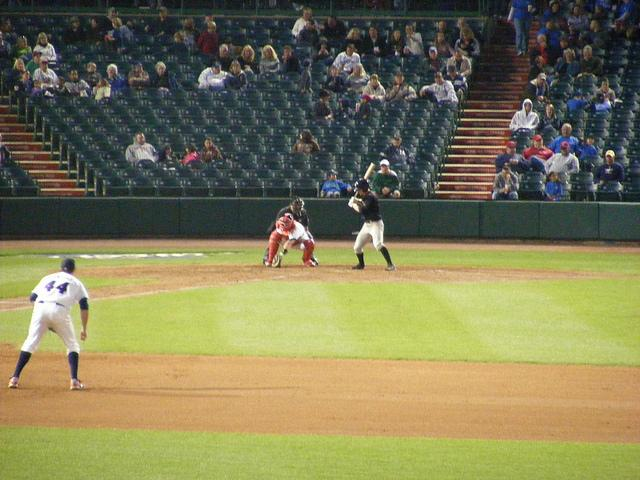How does the temperature likely feel? Please explain your reasoning. cool. Judging by the clothing being worn by the people in the stands, they are wearing more clothing than one would on a warm day, but less that one would on a very cold day so the temperature is likely in the middle. 